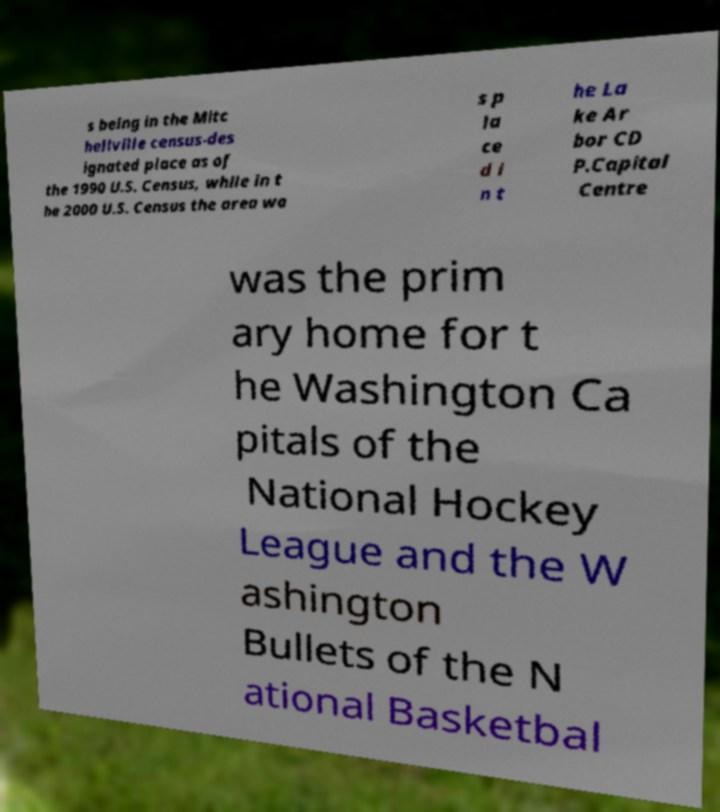What messages or text are displayed in this image? I need them in a readable, typed format. s being in the Mitc hellville census-des ignated place as of the 1990 U.S. Census, while in t he 2000 U.S. Census the area wa s p la ce d i n t he La ke Ar bor CD P.Capital Centre was the prim ary home for t he Washington Ca pitals of the National Hockey League and the W ashington Bullets of the N ational Basketbal 